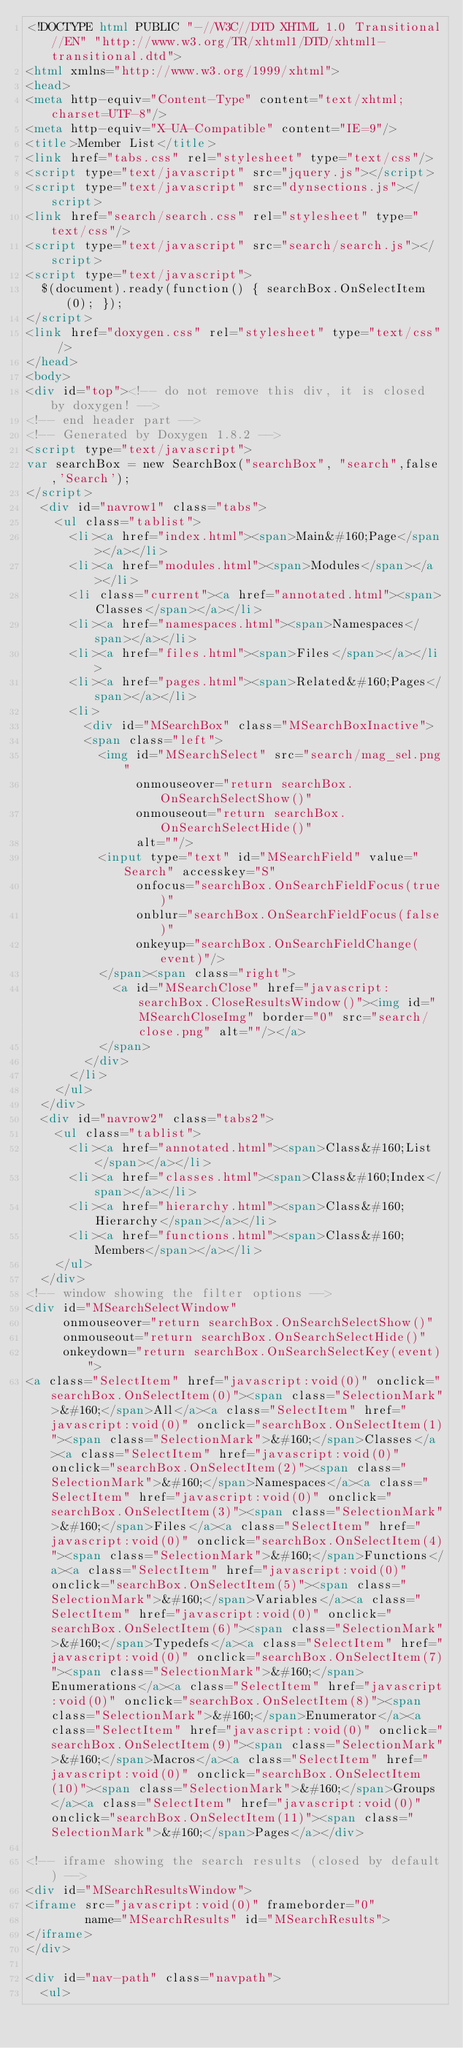<code> <loc_0><loc_0><loc_500><loc_500><_HTML_><!DOCTYPE html PUBLIC "-//W3C//DTD XHTML 1.0 Transitional//EN" "http://www.w3.org/TR/xhtml1/DTD/xhtml1-transitional.dtd">
<html xmlns="http://www.w3.org/1999/xhtml">
<head>
<meta http-equiv="Content-Type" content="text/xhtml;charset=UTF-8"/>
<meta http-equiv="X-UA-Compatible" content="IE=9"/>
<title>Member List</title>
<link href="tabs.css" rel="stylesheet" type="text/css"/>
<script type="text/javascript" src="jquery.js"></script>
<script type="text/javascript" src="dynsections.js"></script>
<link href="search/search.css" rel="stylesheet" type="text/css"/>
<script type="text/javascript" src="search/search.js"></script>
<script type="text/javascript">
  $(document).ready(function() { searchBox.OnSelectItem(0); });
</script>
<link href="doxygen.css" rel="stylesheet" type="text/css" />
</head>
<body>
<div id="top"><!-- do not remove this div, it is closed by doxygen! -->
<!-- end header part -->
<!-- Generated by Doxygen 1.8.2 -->
<script type="text/javascript">
var searchBox = new SearchBox("searchBox", "search",false,'Search');
</script>
  <div id="navrow1" class="tabs">
    <ul class="tablist">
      <li><a href="index.html"><span>Main&#160;Page</span></a></li>
      <li><a href="modules.html"><span>Modules</span></a></li>
      <li class="current"><a href="annotated.html"><span>Classes</span></a></li>
      <li><a href="namespaces.html"><span>Namespaces</span></a></li>
      <li><a href="files.html"><span>Files</span></a></li>
      <li><a href="pages.html"><span>Related&#160;Pages</span></a></li>
      <li>
        <div id="MSearchBox" class="MSearchBoxInactive">
        <span class="left">
          <img id="MSearchSelect" src="search/mag_sel.png"
               onmouseover="return searchBox.OnSearchSelectShow()"
               onmouseout="return searchBox.OnSearchSelectHide()"
               alt=""/>
          <input type="text" id="MSearchField" value="Search" accesskey="S"
               onfocus="searchBox.OnSearchFieldFocus(true)" 
               onblur="searchBox.OnSearchFieldFocus(false)" 
               onkeyup="searchBox.OnSearchFieldChange(event)"/>
          </span><span class="right">
            <a id="MSearchClose" href="javascript:searchBox.CloseResultsWindow()"><img id="MSearchCloseImg" border="0" src="search/close.png" alt=""/></a>
          </span>
        </div>
      </li>
    </ul>
  </div>
  <div id="navrow2" class="tabs2">
    <ul class="tablist">
      <li><a href="annotated.html"><span>Class&#160;List</span></a></li>
      <li><a href="classes.html"><span>Class&#160;Index</span></a></li>
      <li><a href="hierarchy.html"><span>Class&#160;Hierarchy</span></a></li>
      <li><a href="functions.html"><span>Class&#160;Members</span></a></li>
    </ul>
  </div>
<!-- window showing the filter options -->
<div id="MSearchSelectWindow"
     onmouseover="return searchBox.OnSearchSelectShow()"
     onmouseout="return searchBox.OnSearchSelectHide()"
     onkeydown="return searchBox.OnSearchSelectKey(event)">
<a class="SelectItem" href="javascript:void(0)" onclick="searchBox.OnSelectItem(0)"><span class="SelectionMark">&#160;</span>All</a><a class="SelectItem" href="javascript:void(0)" onclick="searchBox.OnSelectItem(1)"><span class="SelectionMark">&#160;</span>Classes</a><a class="SelectItem" href="javascript:void(0)" onclick="searchBox.OnSelectItem(2)"><span class="SelectionMark">&#160;</span>Namespaces</a><a class="SelectItem" href="javascript:void(0)" onclick="searchBox.OnSelectItem(3)"><span class="SelectionMark">&#160;</span>Files</a><a class="SelectItem" href="javascript:void(0)" onclick="searchBox.OnSelectItem(4)"><span class="SelectionMark">&#160;</span>Functions</a><a class="SelectItem" href="javascript:void(0)" onclick="searchBox.OnSelectItem(5)"><span class="SelectionMark">&#160;</span>Variables</a><a class="SelectItem" href="javascript:void(0)" onclick="searchBox.OnSelectItem(6)"><span class="SelectionMark">&#160;</span>Typedefs</a><a class="SelectItem" href="javascript:void(0)" onclick="searchBox.OnSelectItem(7)"><span class="SelectionMark">&#160;</span>Enumerations</a><a class="SelectItem" href="javascript:void(0)" onclick="searchBox.OnSelectItem(8)"><span class="SelectionMark">&#160;</span>Enumerator</a><a class="SelectItem" href="javascript:void(0)" onclick="searchBox.OnSelectItem(9)"><span class="SelectionMark">&#160;</span>Macros</a><a class="SelectItem" href="javascript:void(0)" onclick="searchBox.OnSelectItem(10)"><span class="SelectionMark">&#160;</span>Groups</a><a class="SelectItem" href="javascript:void(0)" onclick="searchBox.OnSelectItem(11)"><span class="SelectionMark">&#160;</span>Pages</a></div>

<!-- iframe showing the search results (closed by default) -->
<div id="MSearchResultsWindow">
<iframe src="javascript:void(0)" frameborder="0" 
        name="MSearchResults" id="MSearchResults">
</iframe>
</div>

<div id="nav-path" class="navpath">
  <ul></code> 